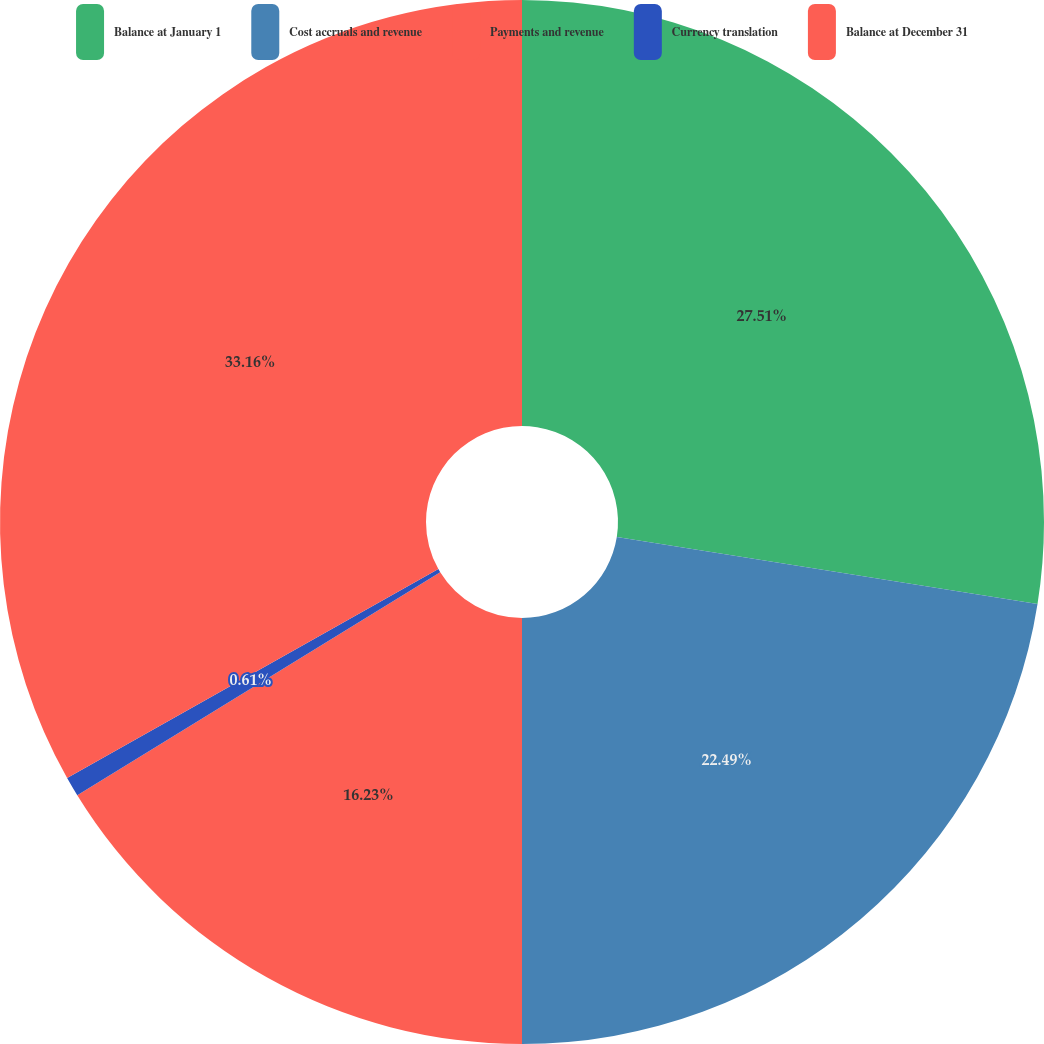Convert chart. <chart><loc_0><loc_0><loc_500><loc_500><pie_chart><fcel>Balance at January 1<fcel>Cost accruals and revenue<fcel>Payments and revenue<fcel>Currency translation<fcel>Balance at December 31<nl><fcel>27.51%<fcel>22.49%<fcel>16.23%<fcel>0.61%<fcel>33.16%<nl></chart> 